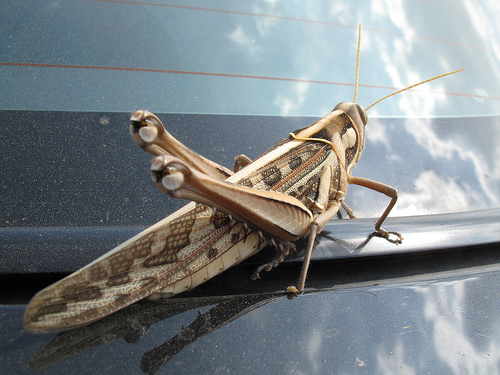<image>
Is there a grass hopper behind the hood? Yes. From this viewpoint, the grass hopper is positioned behind the hood, with the hood partially or fully occluding the grass hopper. 